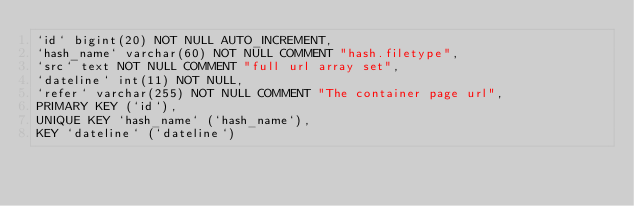<code> <loc_0><loc_0><loc_500><loc_500><_SQL_>`id` bigint(20) NOT NULL AUTO_INCREMENT,
`hash_name` varchar(60) NOT NULL COMMENT "hash.filetype",
`src` text NOT NULL COMMENT "full url array set",
`dateline` int(11) NOT NULL,
`refer` varchar(255) NOT NULL COMMENT "The container page url",
PRIMARY KEY (`id`),
UNIQUE KEY `hash_name` (`hash_name`),
KEY `dateline` (`dateline`)
</code> 